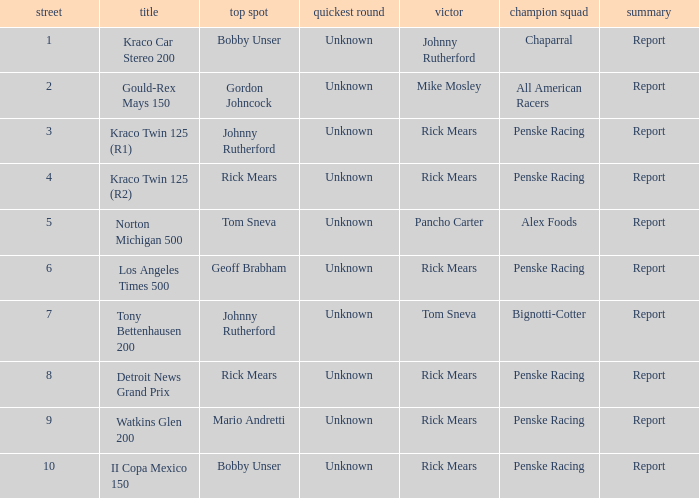The race tony bettenhausen 200 has what smallest rd? 7.0. 